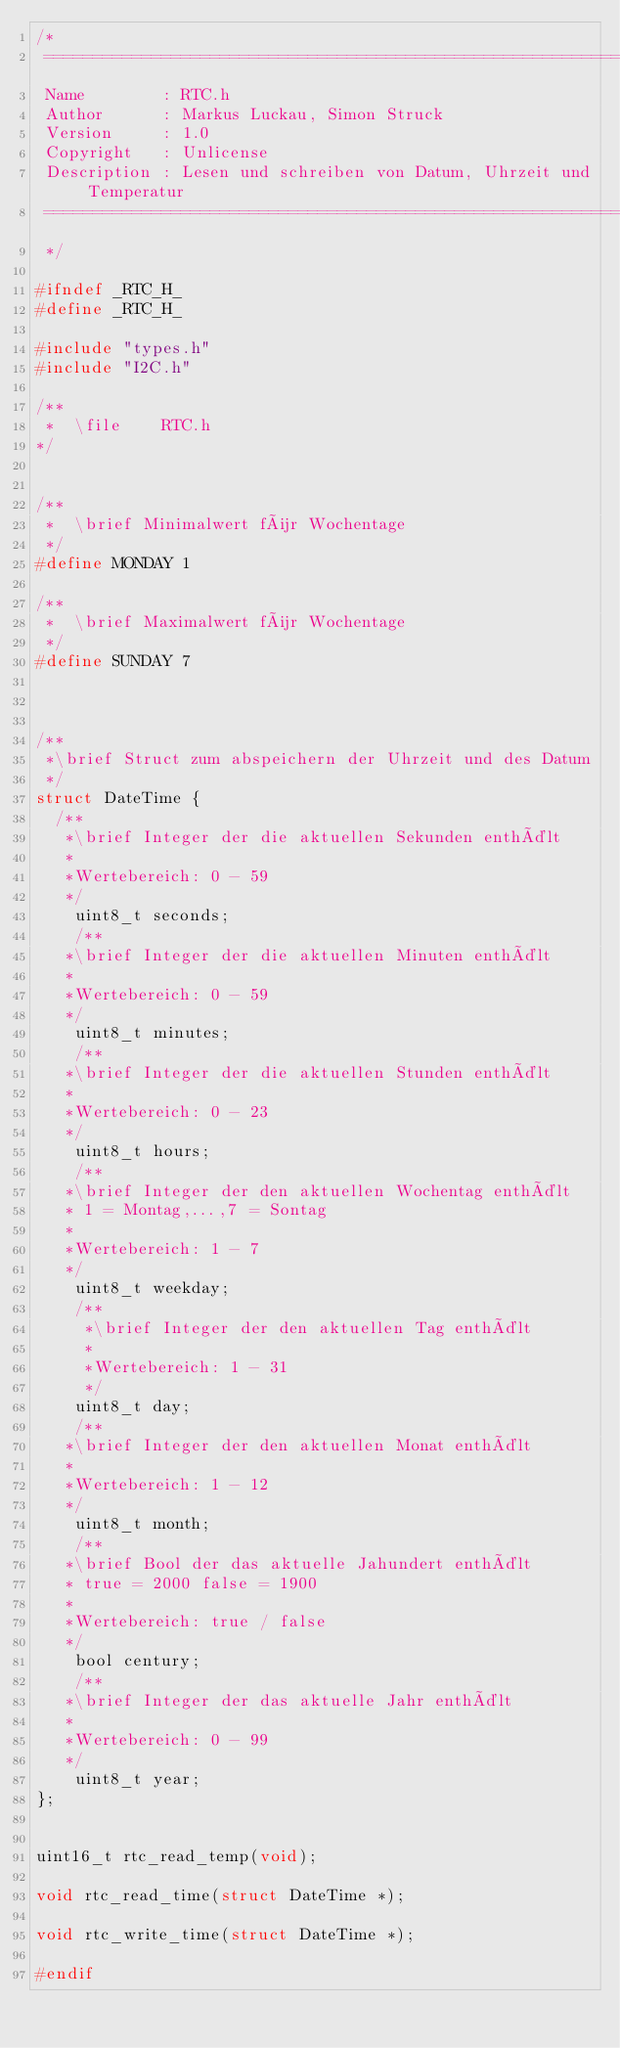Convert code to text. <code><loc_0><loc_0><loc_500><loc_500><_C_>/*
 ===============================================================================
 Name        : RTC.h
 Author      : Markus Luckau, Simon Struck
 Version     : 1.0
 Copyright   : Unlicense
 Description : Lesen und schreiben von Datum, Uhrzeit und Temperatur
 ===============================================================================
 */

#ifndef _RTC_H_
#define _RTC_H_

#include "types.h"
#include "I2C.h"

/**
 *  \file    RTC.h
*/


/**
 *  \brief Minimalwert für Wochentage
 */
#define MONDAY 1

/**
 *  \brief Maximalwert für Wochentage
 */
#define SUNDAY 7



/**
 *\brief Struct zum abspeichern der Uhrzeit und des Datum
 */
struct DateTime {
	/**
	 *\brief Integer der die aktuellen Sekunden enthält
	 *
	 *Wertebereich: 0 - 59
	 */
    uint8_t seconds;
    /**
	 *\brief Integer der die aktuellen Minuten enthält
	 *
	 *Wertebereich: 0 - 59
	 */
    uint8_t minutes;
    /**
	 *\brief Integer der die aktuellen Stunden enthält
	 *
	 *Wertebereich: 0 - 23
	 */
    uint8_t hours;
    /**
	 *\brief Integer der den aktuellen Wochentag enthält
	 * 1 = Montag,...,7 = Sontag
	 *
	 *Wertebereich: 1 - 7
	 */
    uint8_t weekday;
    /**
   	 *\brief Integer der den aktuellen Tag enthält
   	 *
   	 *Wertebereich: 1 - 31
   	 */
    uint8_t day;
    /**
	 *\brief Integer der den aktuellen Monat enthält
	 *
	 *Wertebereich: 1 - 12
	 */
    uint8_t month;
    /**
	 *\brief Bool der das aktuelle Jahundert enthält
	 * true = 2000 false = 1900
	 *
	 *Wertebereich: true / false
	 */
    bool century;
    /**
	 *\brief Integer der das aktuelle Jahr enthält
	 *
	 *Wertebereich: 0 - 99
	 */
    uint8_t year;
};


uint16_t rtc_read_temp(void);

void rtc_read_time(struct DateTime *);

void rtc_write_time(struct DateTime *);

#endif
</code> 